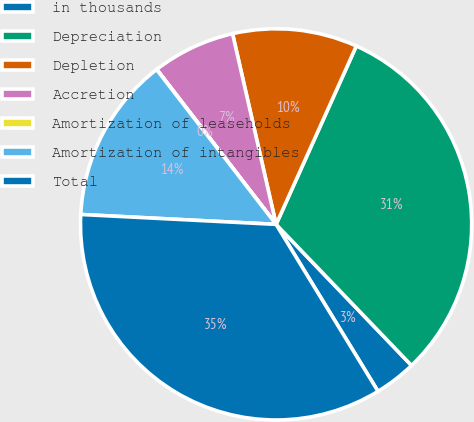<chart> <loc_0><loc_0><loc_500><loc_500><pie_chart><fcel>in thousands<fcel>Depreciation<fcel>Depletion<fcel>Accretion<fcel>Amortization of leaseholds<fcel>Amortization of intangibles<fcel>Total<nl><fcel>3.45%<fcel>31.1%<fcel>10.3%<fcel>6.87%<fcel>0.02%<fcel>13.73%<fcel>34.53%<nl></chart> 